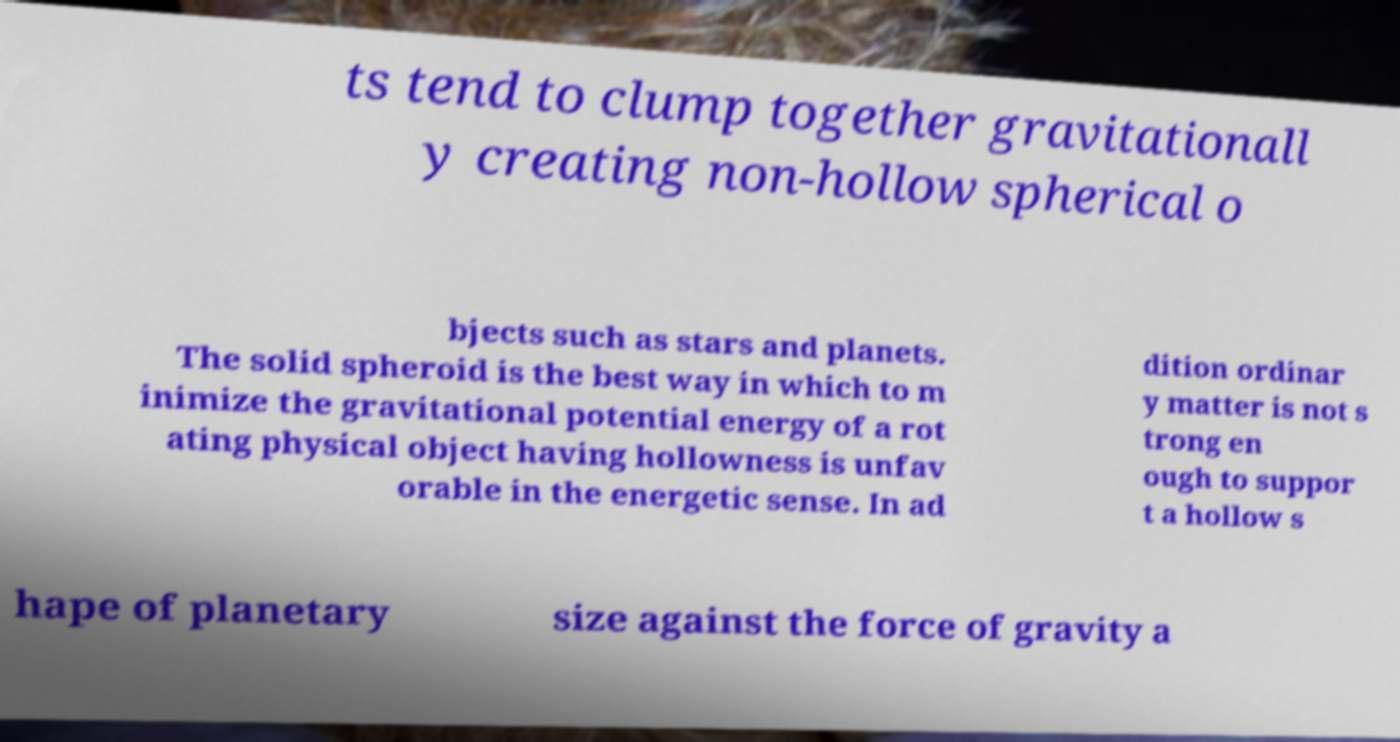I need the written content from this picture converted into text. Can you do that? ts tend to clump together gravitationall y creating non-hollow spherical o bjects such as stars and planets. The solid spheroid is the best way in which to m inimize the gravitational potential energy of a rot ating physical object having hollowness is unfav orable in the energetic sense. In ad dition ordinar y matter is not s trong en ough to suppor t a hollow s hape of planetary size against the force of gravity a 